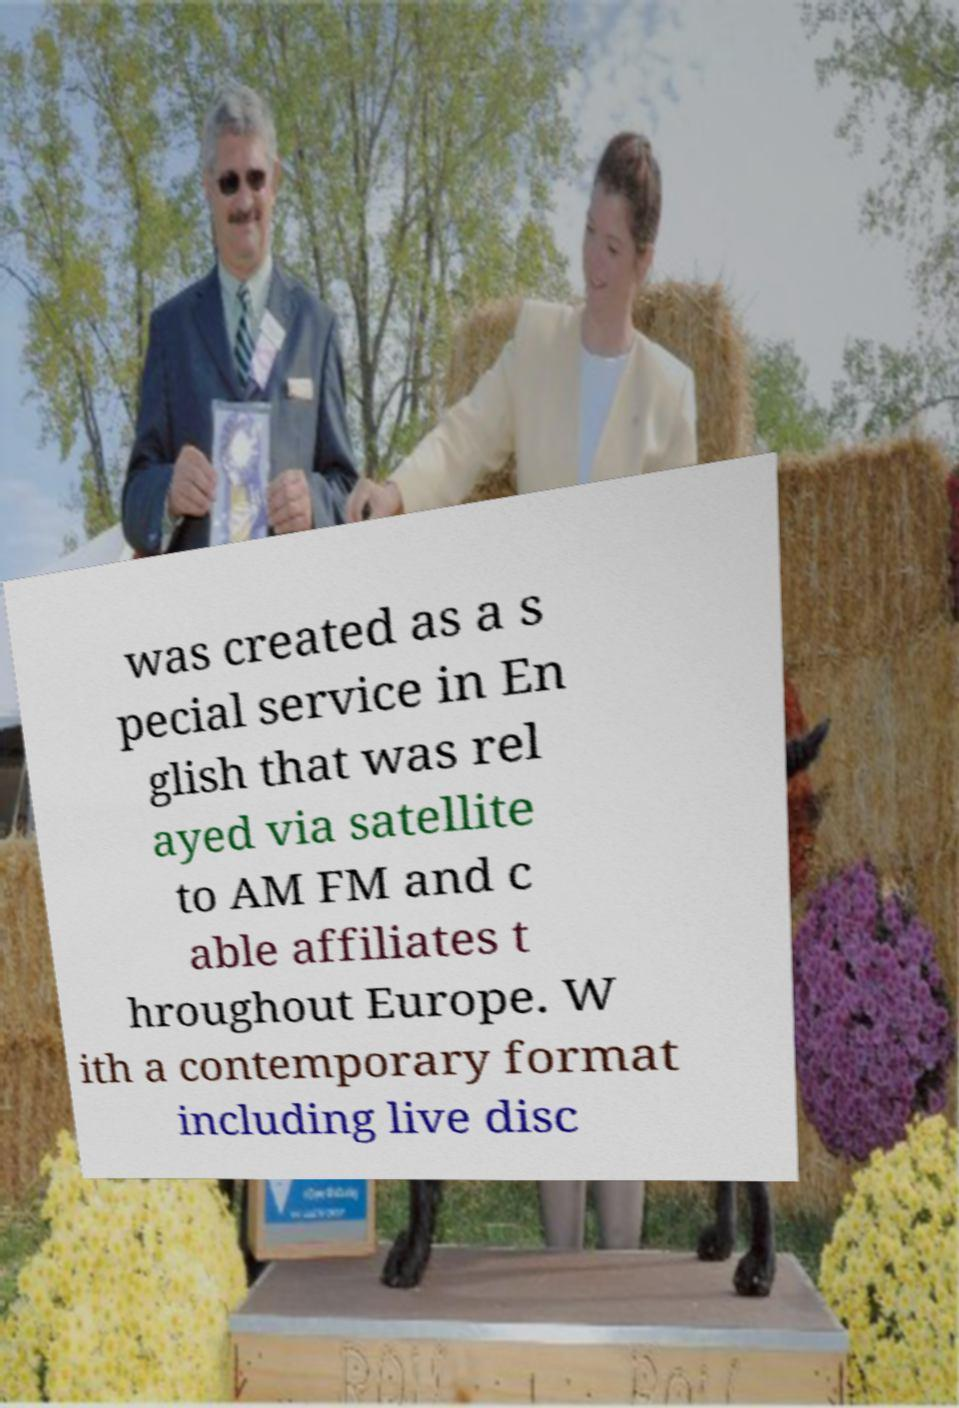What messages or text are displayed in this image? I need them in a readable, typed format. was created as a s pecial service in En glish that was rel ayed via satellite to AM FM and c able affiliates t hroughout Europe. W ith a contemporary format including live disc 